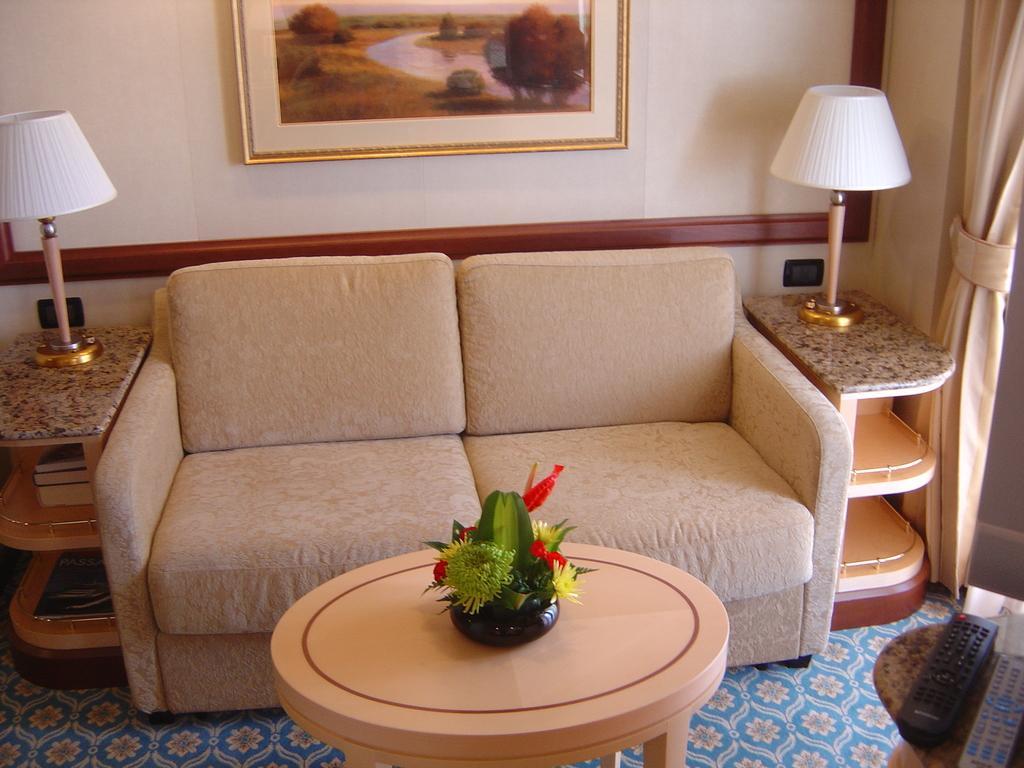In one or two sentences, can you explain what this image depicts? In this picture there is an unoccupied sofa and two lamps on the either sides , there is also a painting attached to the wall. There is also a flower pot on the center table. 